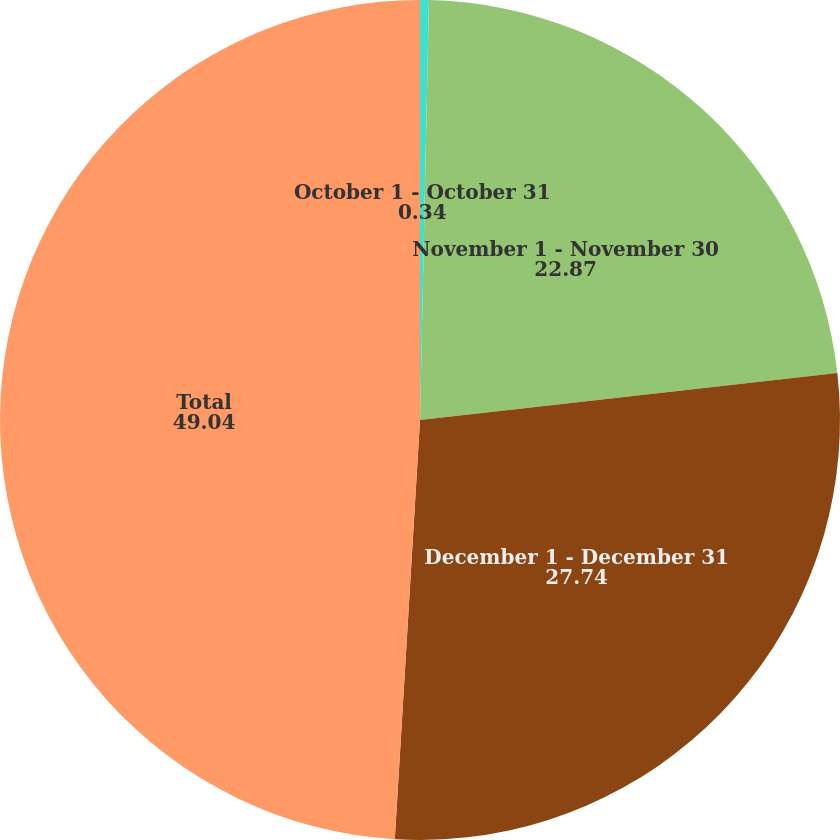Convert chart to OTSL. <chart><loc_0><loc_0><loc_500><loc_500><pie_chart><fcel>October 1 - October 31<fcel>November 1 - November 30<fcel>December 1 - December 31<fcel>Total<nl><fcel>0.34%<fcel>22.87%<fcel>27.74%<fcel>49.04%<nl></chart> 